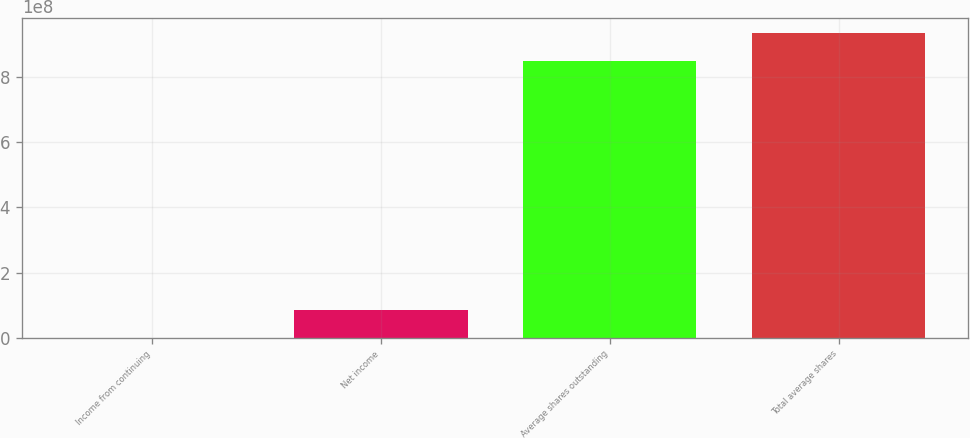<chart> <loc_0><loc_0><loc_500><loc_500><bar_chart><fcel>Income from continuing<fcel>Net income<fcel>Average shares outstanding<fcel>Total average shares<nl><fcel>1581<fcel>8.52349e+07<fcel>8.4874e+08<fcel>9.33974e+08<nl></chart> 